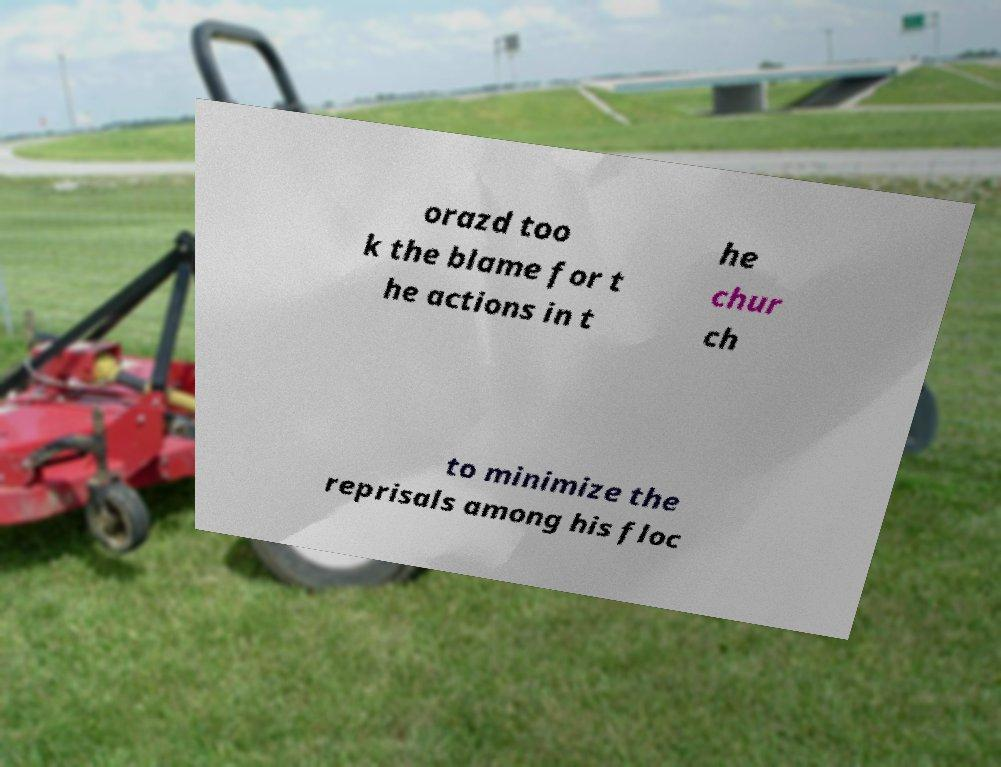Could you assist in decoding the text presented in this image and type it out clearly? orazd too k the blame for t he actions in t he chur ch to minimize the reprisals among his floc 